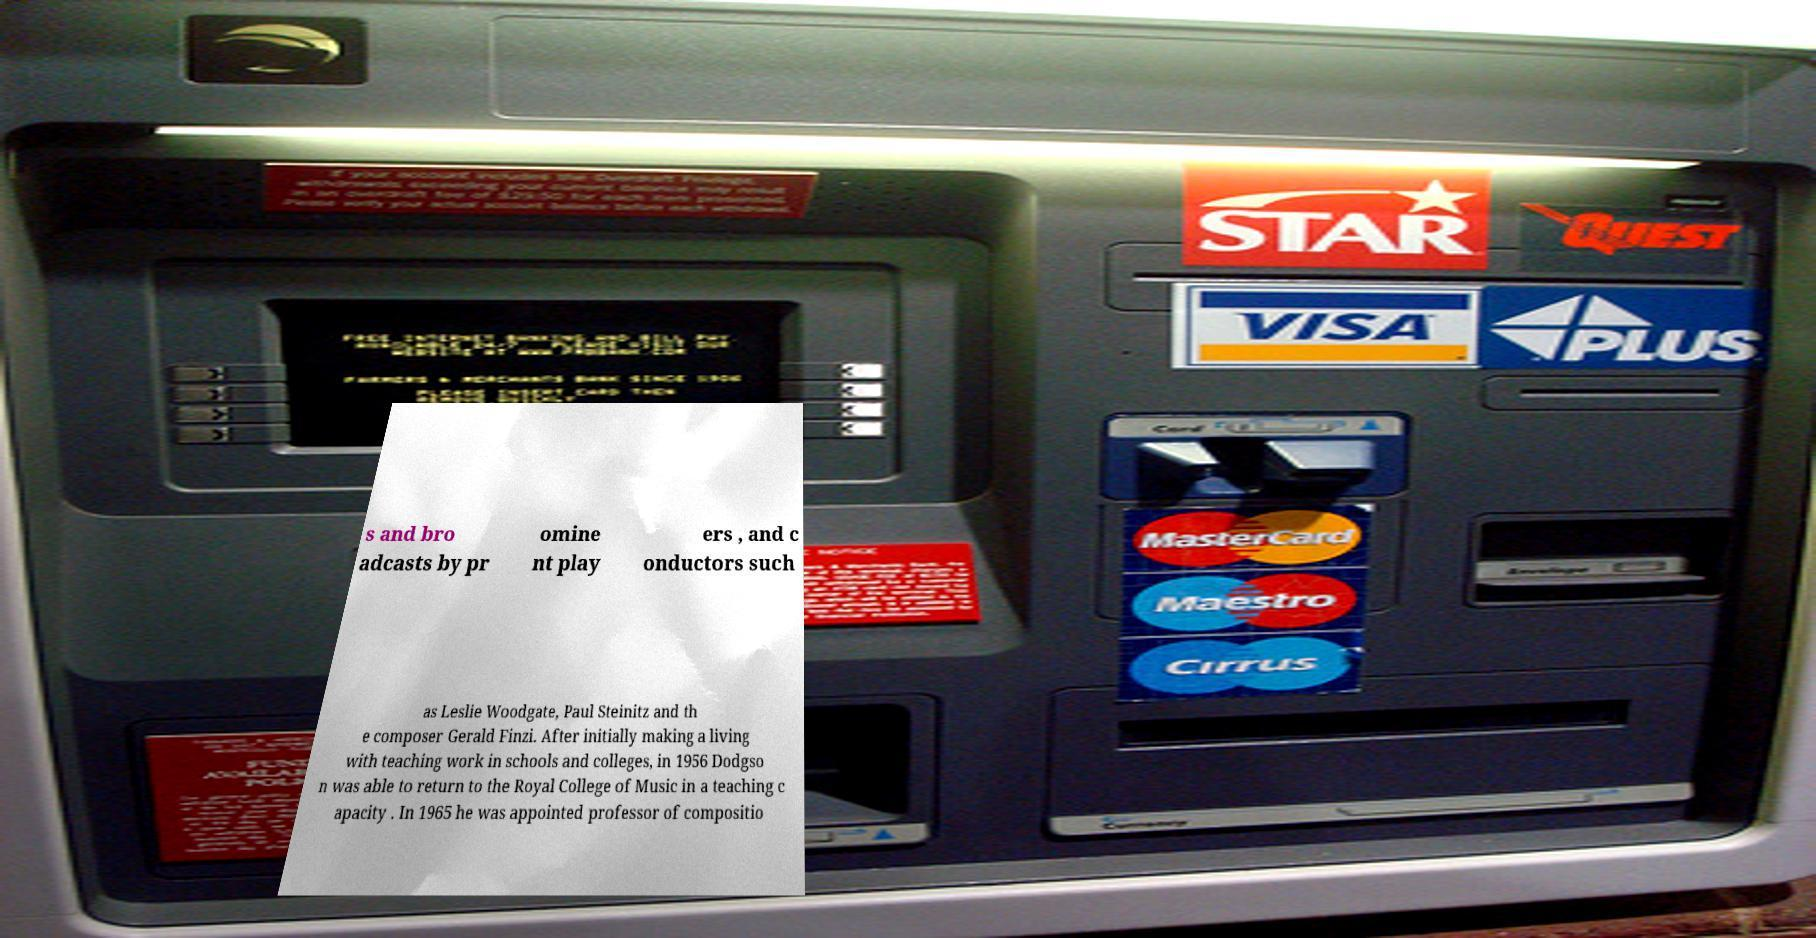Please identify and transcribe the text found in this image. s and bro adcasts by pr omine nt play ers , and c onductors such as Leslie Woodgate, Paul Steinitz and th e composer Gerald Finzi. After initially making a living with teaching work in schools and colleges, in 1956 Dodgso n was able to return to the Royal College of Music in a teaching c apacity . In 1965 he was appointed professor of compositio 